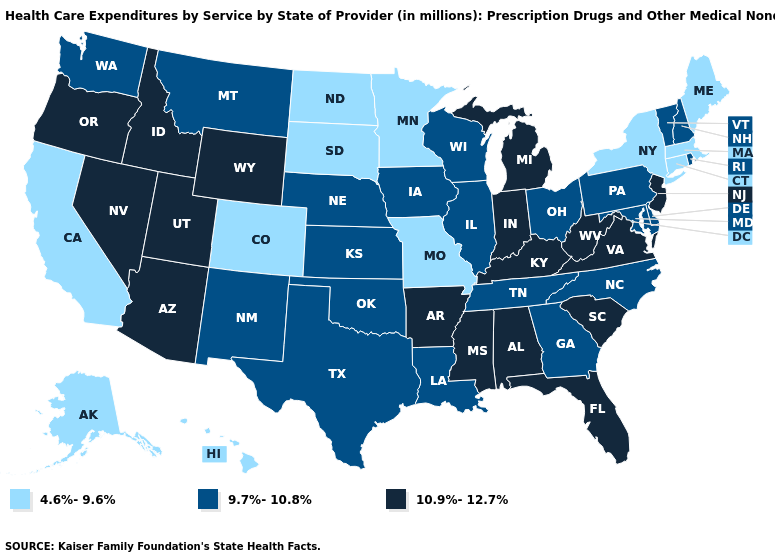Does the map have missing data?
Be succinct. No. Does Florida have the highest value in the South?
Be succinct. Yes. Which states hav the highest value in the West?
Give a very brief answer. Arizona, Idaho, Nevada, Oregon, Utah, Wyoming. What is the highest value in the USA?
Keep it brief. 10.9%-12.7%. What is the value of Ohio?
Keep it brief. 9.7%-10.8%. What is the lowest value in states that border Maryland?
Give a very brief answer. 9.7%-10.8%. Among the states that border Delaware , does New Jersey have the highest value?
Write a very short answer. Yes. Among the states that border Virginia , does Maryland have the highest value?
Short answer required. No. How many symbols are there in the legend?
Quick response, please. 3. Name the states that have a value in the range 9.7%-10.8%?
Be succinct. Delaware, Georgia, Illinois, Iowa, Kansas, Louisiana, Maryland, Montana, Nebraska, New Hampshire, New Mexico, North Carolina, Ohio, Oklahoma, Pennsylvania, Rhode Island, Tennessee, Texas, Vermont, Washington, Wisconsin. Does West Virginia have the same value as Mississippi?
Quick response, please. Yes. Does Texas have the same value as Washington?
Keep it brief. Yes. What is the highest value in the Northeast ?
Write a very short answer. 10.9%-12.7%. Name the states that have a value in the range 4.6%-9.6%?
Concise answer only. Alaska, California, Colorado, Connecticut, Hawaii, Maine, Massachusetts, Minnesota, Missouri, New York, North Dakota, South Dakota. Name the states that have a value in the range 4.6%-9.6%?
Be succinct. Alaska, California, Colorado, Connecticut, Hawaii, Maine, Massachusetts, Minnesota, Missouri, New York, North Dakota, South Dakota. 